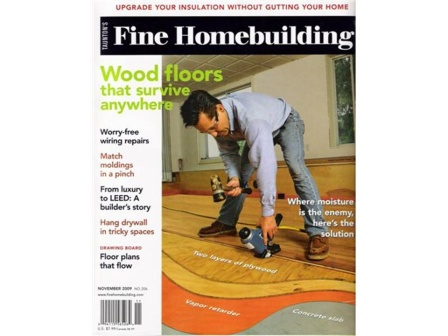What's a likely reason the magazine offers advice on 'Hang drywall in tricky spaces'? Hanging drywall in tricky spaces can be particularly challenging due to irregular wall configurations, tight corners, or obstacles such as pipes and electrical fixtures. The magazine likely offers advice on this topic to help DIY enthusiasts and professionals alike overcome these difficulties. With detailed step-by-step guides, tips on necessary tools, and creative problem-solving strategies, the magazine aims to equip readers with the knowledge to successfully tackle these complex areas, ensuring a smooth and polished finish. 